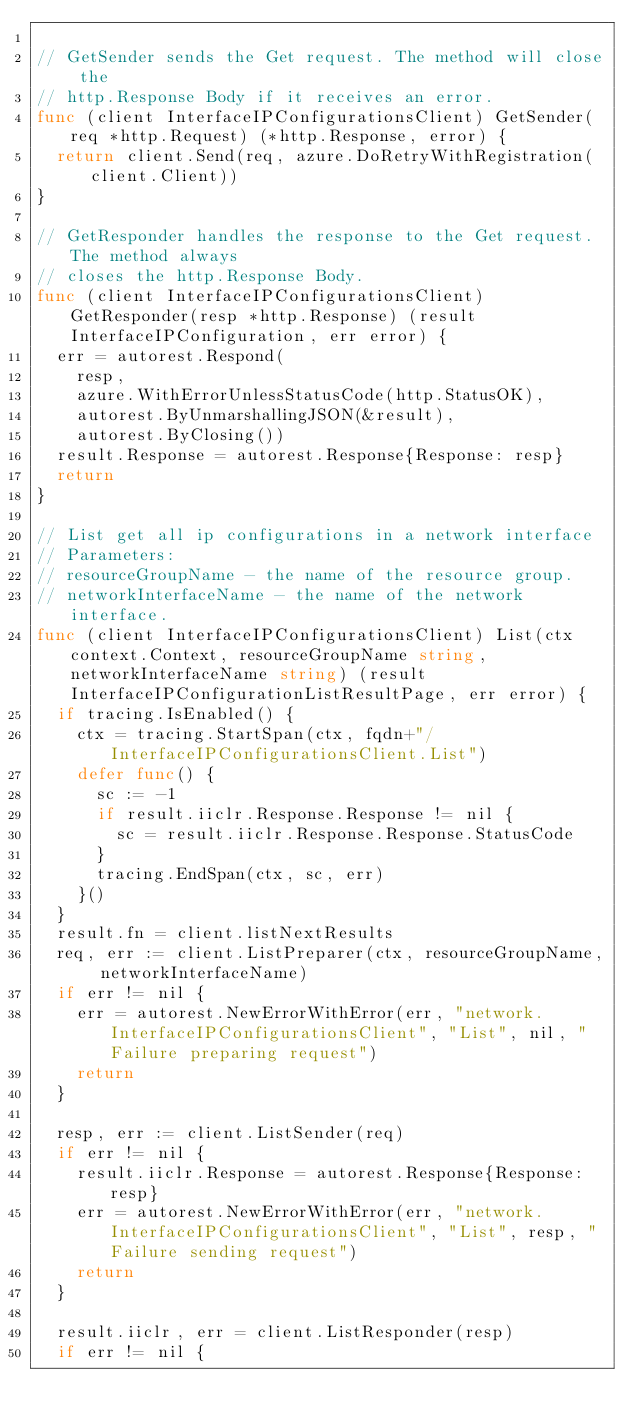<code> <loc_0><loc_0><loc_500><loc_500><_Go_>
// GetSender sends the Get request. The method will close the
// http.Response Body if it receives an error.
func (client InterfaceIPConfigurationsClient) GetSender(req *http.Request) (*http.Response, error) {
	return client.Send(req, azure.DoRetryWithRegistration(client.Client))
}

// GetResponder handles the response to the Get request. The method always
// closes the http.Response Body.
func (client InterfaceIPConfigurationsClient) GetResponder(resp *http.Response) (result InterfaceIPConfiguration, err error) {
	err = autorest.Respond(
		resp,
		azure.WithErrorUnlessStatusCode(http.StatusOK),
		autorest.ByUnmarshallingJSON(&result),
		autorest.ByClosing())
	result.Response = autorest.Response{Response: resp}
	return
}

// List get all ip configurations in a network interface
// Parameters:
// resourceGroupName - the name of the resource group.
// networkInterfaceName - the name of the network interface.
func (client InterfaceIPConfigurationsClient) List(ctx context.Context, resourceGroupName string, networkInterfaceName string) (result InterfaceIPConfigurationListResultPage, err error) {
	if tracing.IsEnabled() {
		ctx = tracing.StartSpan(ctx, fqdn+"/InterfaceIPConfigurationsClient.List")
		defer func() {
			sc := -1
			if result.iiclr.Response.Response != nil {
				sc = result.iiclr.Response.Response.StatusCode
			}
			tracing.EndSpan(ctx, sc, err)
		}()
	}
	result.fn = client.listNextResults
	req, err := client.ListPreparer(ctx, resourceGroupName, networkInterfaceName)
	if err != nil {
		err = autorest.NewErrorWithError(err, "network.InterfaceIPConfigurationsClient", "List", nil, "Failure preparing request")
		return
	}

	resp, err := client.ListSender(req)
	if err != nil {
		result.iiclr.Response = autorest.Response{Response: resp}
		err = autorest.NewErrorWithError(err, "network.InterfaceIPConfigurationsClient", "List", resp, "Failure sending request")
		return
	}

	result.iiclr, err = client.ListResponder(resp)
	if err != nil {</code> 